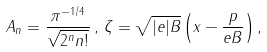<formula> <loc_0><loc_0><loc_500><loc_500>A _ { n } = \frac { \pi ^ { - 1 / 4 } } { \sqrt { 2 ^ { n } n ! } } \, , \, \zeta = \sqrt { | e | B } \left ( x - \frac { p } { e B } \right ) ,</formula> 